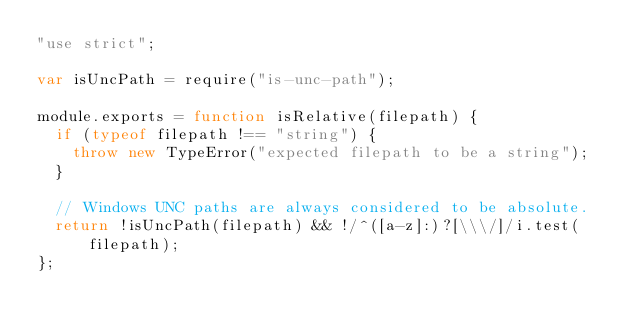<code> <loc_0><loc_0><loc_500><loc_500><_JavaScript_>"use strict";

var isUncPath = require("is-unc-path");

module.exports = function isRelative(filepath) {
  if (typeof filepath !== "string") {
    throw new TypeError("expected filepath to be a string");
  }

  // Windows UNC paths are always considered to be absolute.
  return !isUncPath(filepath) && !/^([a-z]:)?[\\\/]/i.test(filepath);
};
</code> 